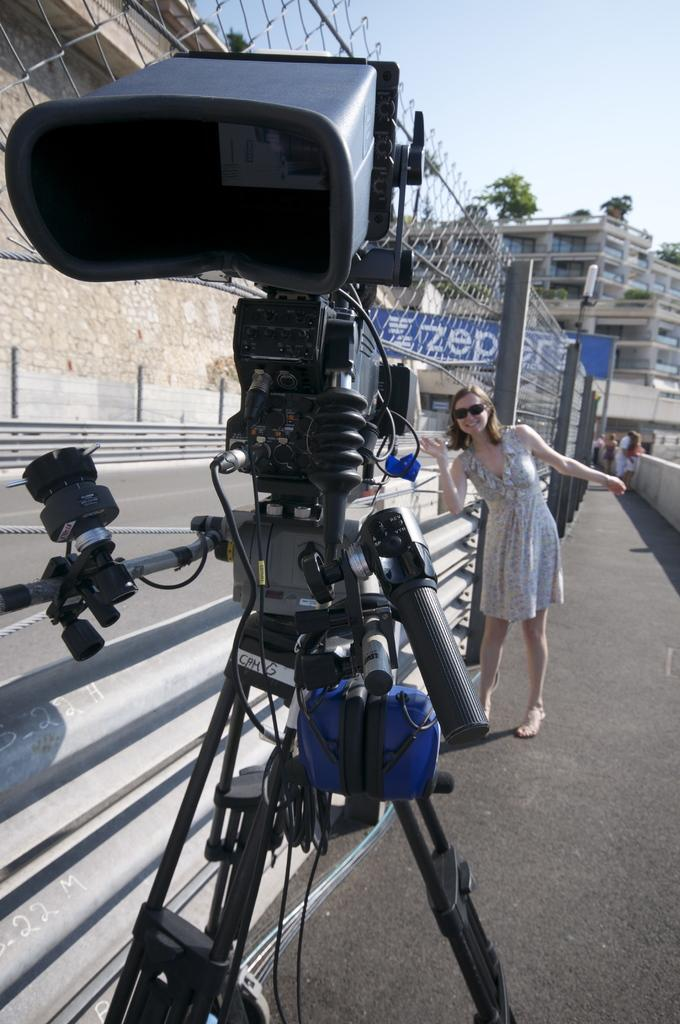What is the main object in the foreground of the image? There is a video camera on a stand in the foreground of the image. What is the lady wearing in the image? The lady is wearing goggles in the image. What can be seen in the background of the image? There is a road, a wall, a railing, banners, buildings, trees, and the sky visible in the background of the image. Can you tell me how many leaves are on the monkey in the image? There is no monkey present in the image, and therefore no leaves can be observed on it. 